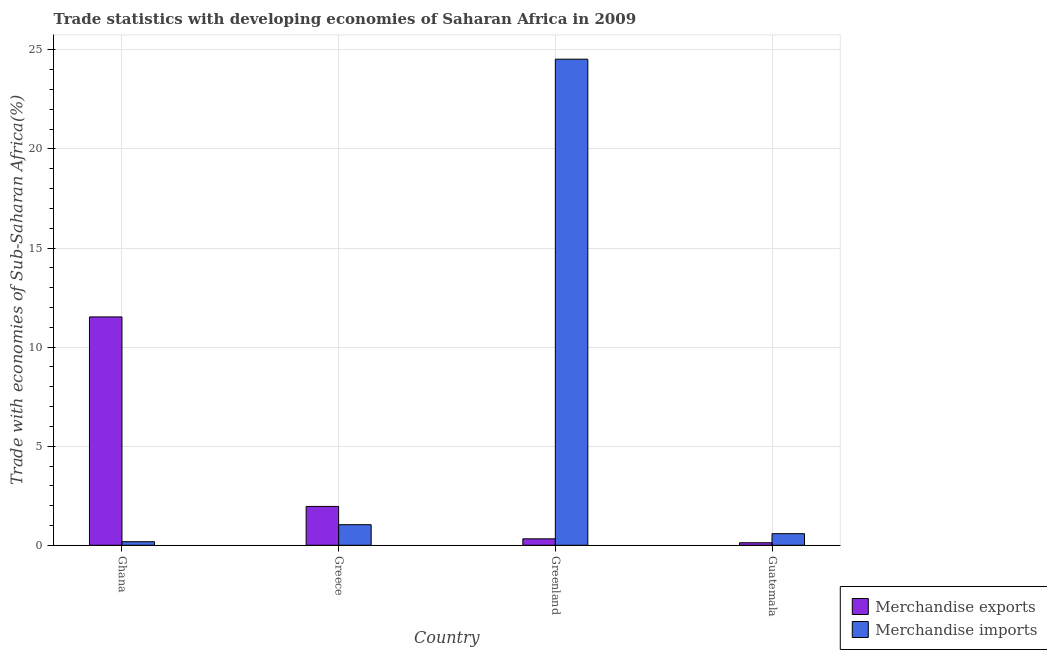How many groups of bars are there?
Keep it short and to the point. 4. Are the number of bars per tick equal to the number of legend labels?
Provide a succinct answer. Yes. How many bars are there on the 1st tick from the left?
Keep it short and to the point. 2. What is the label of the 3rd group of bars from the left?
Make the answer very short. Greenland. What is the merchandise exports in Ghana?
Ensure brevity in your answer.  11.52. Across all countries, what is the maximum merchandise exports?
Keep it short and to the point. 11.52. Across all countries, what is the minimum merchandise exports?
Your answer should be very brief. 0.13. In which country was the merchandise exports minimum?
Provide a short and direct response. Guatemala. What is the total merchandise exports in the graph?
Your response must be concise. 13.94. What is the difference between the merchandise exports in Greece and that in Greenland?
Provide a succinct answer. 1.64. What is the difference between the merchandise imports in Guatemala and the merchandise exports in Greece?
Ensure brevity in your answer.  -1.38. What is the average merchandise imports per country?
Your answer should be very brief. 6.58. What is the difference between the merchandise exports and merchandise imports in Greece?
Offer a terse response. 0.92. What is the ratio of the merchandise exports in Greece to that in Guatemala?
Make the answer very short. 15.36. Is the merchandise exports in Greece less than that in Greenland?
Offer a very short reply. No. What is the difference between the highest and the second highest merchandise exports?
Your response must be concise. 9.56. What is the difference between the highest and the lowest merchandise imports?
Make the answer very short. 24.35. Is the sum of the merchandise imports in Ghana and Guatemala greater than the maximum merchandise exports across all countries?
Ensure brevity in your answer.  No. What does the 2nd bar from the left in Guatemala represents?
Keep it short and to the point. Merchandise imports. What does the 2nd bar from the right in Greenland represents?
Your answer should be compact. Merchandise exports. How many bars are there?
Offer a very short reply. 8. How many countries are there in the graph?
Your response must be concise. 4. What is the difference between two consecutive major ticks on the Y-axis?
Make the answer very short. 5. What is the title of the graph?
Make the answer very short. Trade statistics with developing economies of Saharan Africa in 2009. What is the label or title of the X-axis?
Offer a terse response. Country. What is the label or title of the Y-axis?
Offer a terse response. Trade with economies of Sub-Saharan Africa(%). What is the Trade with economies of Sub-Saharan Africa(%) of Merchandise exports in Ghana?
Your response must be concise. 11.52. What is the Trade with economies of Sub-Saharan Africa(%) of Merchandise imports in Ghana?
Give a very brief answer. 0.18. What is the Trade with economies of Sub-Saharan Africa(%) in Merchandise exports in Greece?
Your answer should be compact. 1.96. What is the Trade with economies of Sub-Saharan Africa(%) of Merchandise imports in Greece?
Provide a succinct answer. 1.04. What is the Trade with economies of Sub-Saharan Africa(%) in Merchandise exports in Greenland?
Your answer should be very brief. 0.33. What is the Trade with economies of Sub-Saharan Africa(%) of Merchandise imports in Greenland?
Ensure brevity in your answer.  24.53. What is the Trade with economies of Sub-Saharan Africa(%) in Merchandise exports in Guatemala?
Your answer should be compact. 0.13. What is the Trade with economies of Sub-Saharan Africa(%) in Merchandise imports in Guatemala?
Give a very brief answer. 0.58. Across all countries, what is the maximum Trade with economies of Sub-Saharan Africa(%) in Merchandise exports?
Provide a succinct answer. 11.52. Across all countries, what is the maximum Trade with economies of Sub-Saharan Africa(%) of Merchandise imports?
Your answer should be compact. 24.53. Across all countries, what is the minimum Trade with economies of Sub-Saharan Africa(%) of Merchandise exports?
Provide a succinct answer. 0.13. Across all countries, what is the minimum Trade with economies of Sub-Saharan Africa(%) of Merchandise imports?
Your response must be concise. 0.18. What is the total Trade with economies of Sub-Saharan Africa(%) in Merchandise exports in the graph?
Make the answer very short. 13.94. What is the total Trade with economies of Sub-Saharan Africa(%) of Merchandise imports in the graph?
Ensure brevity in your answer.  26.34. What is the difference between the Trade with economies of Sub-Saharan Africa(%) of Merchandise exports in Ghana and that in Greece?
Offer a terse response. 9.56. What is the difference between the Trade with economies of Sub-Saharan Africa(%) in Merchandise imports in Ghana and that in Greece?
Offer a terse response. -0.86. What is the difference between the Trade with economies of Sub-Saharan Africa(%) in Merchandise exports in Ghana and that in Greenland?
Keep it short and to the point. 11.2. What is the difference between the Trade with economies of Sub-Saharan Africa(%) of Merchandise imports in Ghana and that in Greenland?
Offer a terse response. -24.35. What is the difference between the Trade with economies of Sub-Saharan Africa(%) in Merchandise exports in Ghana and that in Guatemala?
Make the answer very short. 11.4. What is the difference between the Trade with economies of Sub-Saharan Africa(%) in Merchandise imports in Ghana and that in Guatemala?
Offer a terse response. -0.4. What is the difference between the Trade with economies of Sub-Saharan Africa(%) of Merchandise exports in Greece and that in Greenland?
Provide a short and direct response. 1.64. What is the difference between the Trade with economies of Sub-Saharan Africa(%) of Merchandise imports in Greece and that in Greenland?
Your answer should be compact. -23.49. What is the difference between the Trade with economies of Sub-Saharan Africa(%) of Merchandise exports in Greece and that in Guatemala?
Provide a succinct answer. 1.83. What is the difference between the Trade with economies of Sub-Saharan Africa(%) in Merchandise imports in Greece and that in Guatemala?
Your answer should be very brief. 0.45. What is the difference between the Trade with economies of Sub-Saharan Africa(%) in Merchandise exports in Greenland and that in Guatemala?
Offer a very short reply. 0.2. What is the difference between the Trade with economies of Sub-Saharan Africa(%) of Merchandise imports in Greenland and that in Guatemala?
Offer a terse response. 23.95. What is the difference between the Trade with economies of Sub-Saharan Africa(%) of Merchandise exports in Ghana and the Trade with economies of Sub-Saharan Africa(%) of Merchandise imports in Greece?
Provide a succinct answer. 10.49. What is the difference between the Trade with economies of Sub-Saharan Africa(%) of Merchandise exports in Ghana and the Trade with economies of Sub-Saharan Africa(%) of Merchandise imports in Greenland?
Make the answer very short. -13.01. What is the difference between the Trade with economies of Sub-Saharan Africa(%) of Merchandise exports in Ghana and the Trade with economies of Sub-Saharan Africa(%) of Merchandise imports in Guatemala?
Your answer should be very brief. 10.94. What is the difference between the Trade with economies of Sub-Saharan Africa(%) of Merchandise exports in Greece and the Trade with economies of Sub-Saharan Africa(%) of Merchandise imports in Greenland?
Your response must be concise. -22.57. What is the difference between the Trade with economies of Sub-Saharan Africa(%) in Merchandise exports in Greece and the Trade with economies of Sub-Saharan Africa(%) in Merchandise imports in Guatemala?
Make the answer very short. 1.38. What is the difference between the Trade with economies of Sub-Saharan Africa(%) of Merchandise exports in Greenland and the Trade with economies of Sub-Saharan Africa(%) of Merchandise imports in Guatemala?
Give a very brief answer. -0.26. What is the average Trade with economies of Sub-Saharan Africa(%) in Merchandise exports per country?
Provide a succinct answer. 3.48. What is the average Trade with economies of Sub-Saharan Africa(%) of Merchandise imports per country?
Provide a short and direct response. 6.58. What is the difference between the Trade with economies of Sub-Saharan Africa(%) in Merchandise exports and Trade with economies of Sub-Saharan Africa(%) in Merchandise imports in Ghana?
Offer a terse response. 11.34. What is the difference between the Trade with economies of Sub-Saharan Africa(%) in Merchandise exports and Trade with economies of Sub-Saharan Africa(%) in Merchandise imports in Greece?
Ensure brevity in your answer.  0.92. What is the difference between the Trade with economies of Sub-Saharan Africa(%) in Merchandise exports and Trade with economies of Sub-Saharan Africa(%) in Merchandise imports in Greenland?
Provide a succinct answer. -24.21. What is the difference between the Trade with economies of Sub-Saharan Africa(%) of Merchandise exports and Trade with economies of Sub-Saharan Africa(%) of Merchandise imports in Guatemala?
Give a very brief answer. -0.46. What is the ratio of the Trade with economies of Sub-Saharan Africa(%) of Merchandise exports in Ghana to that in Greece?
Your response must be concise. 5.88. What is the ratio of the Trade with economies of Sub-Saharan Africa(%) in Merchandise imports in Ghana to that in Greece?
Make the answer very short. 0.17. What is the ratio of the Trade with economies of Sub-Saharan Africa(%) in Merchandise exports in Ghana to that in Greenland?
Ensure brevity in your answer.  35.41. What is the ratio of the Trade with economies of Sub-Saharan Africa(%) in Merchandise imports in Ghana to that in Greenland?
Make the answer very short. 0.01. What is the ratio of the Trade with economies of Sub-Saharan Africa(%) in Merchandise exports in Ghana to that in Guatemala?
Give a very brief answer. 90.28. What is the ratio of the Trade with economies of Sub-Saharan Africa(%) in Merchandise imports in Ghana to that in Guatemala?
Provide a succinct answer. 0.31. What is the ratio of the Trade with economies of Sub-Saharan Africa(%) of Merchandise exports in Greece to that in Greenland?
Your answer should be compact. 6.02. What is the ratio of the Trade with economies of Sub-Saharan Africa(%) of Merchandise imports in Greece to that in Greenland?
Make the answer very short. 0.04. What is the ratio of the Trade with economies of Sub-Saharan Africa(%) of Merchandise exports in Greece to that in Guatemala?
Ensure brevity in your answer.  15.36. What is the ratio of the Trade with economies of Sub-Saharan Africa(%) in Merchandise imports in Greece to that in Guatemala?
Ensure brevity in your answer.  1.78. What is the ratio of the Trade with economies of Sub-Saharan Africa(%) of Merchandise exports in Greenland to that in Guatemala?
Provide a short and direct response. 2.55. What is the ratio of the Trade with economies of Sub-Saharan Africa(%) in Merchandise imports in Greenland to that in Guatemala?
Offer a terse response. 41.94. What is the difference between the highest and the second highest Trade with economies of Sub-Saharan Africa(%) in Merchandise exports?
Give a very brief answer. 9.56. What is the difference between the highest and the second highest Trade with economies of Sub-Saharan Africa(%) in Merchandise imports?
Ensure brevity in your answer.  23.49. What is the difference between the highest and the lowest Trade with economies of Sub-Saharan Africa(%) of Merchandise exports?
Provide a succinct answer. 11.4. What is the difference between the highest and the lowest Trade with economies of Sub-Saharan Africa(%) in Merchandise imports?
Keep it short and to the point. 24.35. 